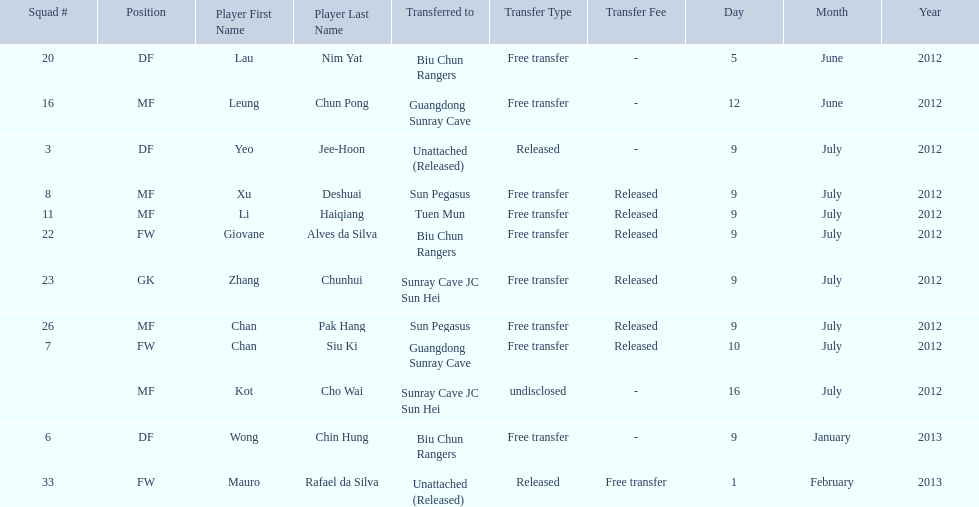Would you mind parsing the complete table? {'header': ['Squad #', 'Position', 'Player First Name', 'Player Last Name', 'Transferred to', 'Transfer Type', 'Transfer Fee', 'Day', 'Month', 'Year'], 'rows': [['20', 'DF', 'Lau', 'Nim Yat', 'Biu Chun Rangers', 'Free transfer', '-', '5', 'June', '2012'], ['16', 'MF', 'Leung', 'Chun Pong', 'Guangdong Sunray Cave', 'Free transfer', '-', '12', 'June', '2012'], ['3', 'DF', 'Yeo', 'Jee-Hoon', 'Unattached (Released)', 'Released', '-', '9', 'July', '2012'], ['8', 'MF', 'Xu', 'Deshuai', 'Sun Pegasus', 'Free transfer', 'Released', '9', 'July', '2012'], ['11', 'MF', 'Li', 'Haiqiang', 'Tuen Mun', 'Free transfer', 'Released', '9', 'July', '2012'], ['22', 'FW', 'Giovane', 'Alves da Silva', 'Biu Chun Rangers', 'Free transfer', 'Released', '9', 'July', '2012'], ['23', 'GK', 'Zhang', 'Chunhui', 'Sunray Cave JC Sun Hei', 'Free transfer', 'Released', '9', 'July', '2012'], ['26', 'MF', 'Chan', 'Pak Hang', 'Sun Pegasus', 'Free transfer', 'Released', '9', 'July', '2012'], ['7', 'FW', 'Chan', 'Siu Ki', 'Guangdong Sunray Cave', 'Free transfer', 'Released', '10', 'July', '2012'], ['', 'MF', 'Kot', 'Cho Wai', 'Sunray Cave JC Sun Hei', 'undisclosed', '-', '16', 'July', '2012'], ['6', 'DF', 'Wong', 'Chin Hung', 'Biu Chun Rangers', 'Free transfer', '-', '9', 'January', '2013'], ['33', 'FW', 'Mauro', 'Rafael da Silva', 'Unattached (Released)', 'Released', 'Free transfer', '1', 'February', '2013']]} What position is next to squad # 3? DF. 